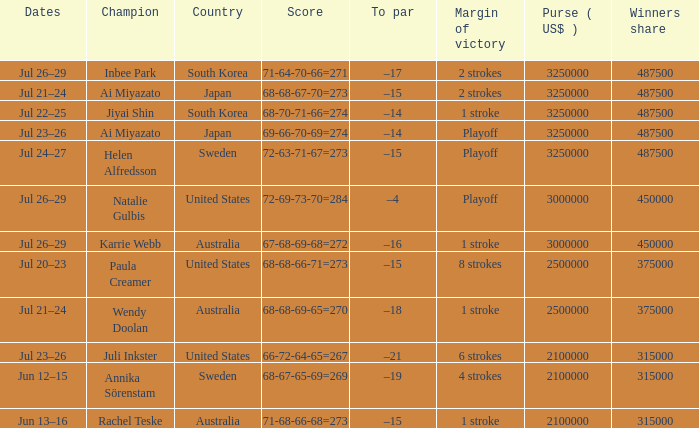How many years was Jiyai Shin the champion? 1.0. 